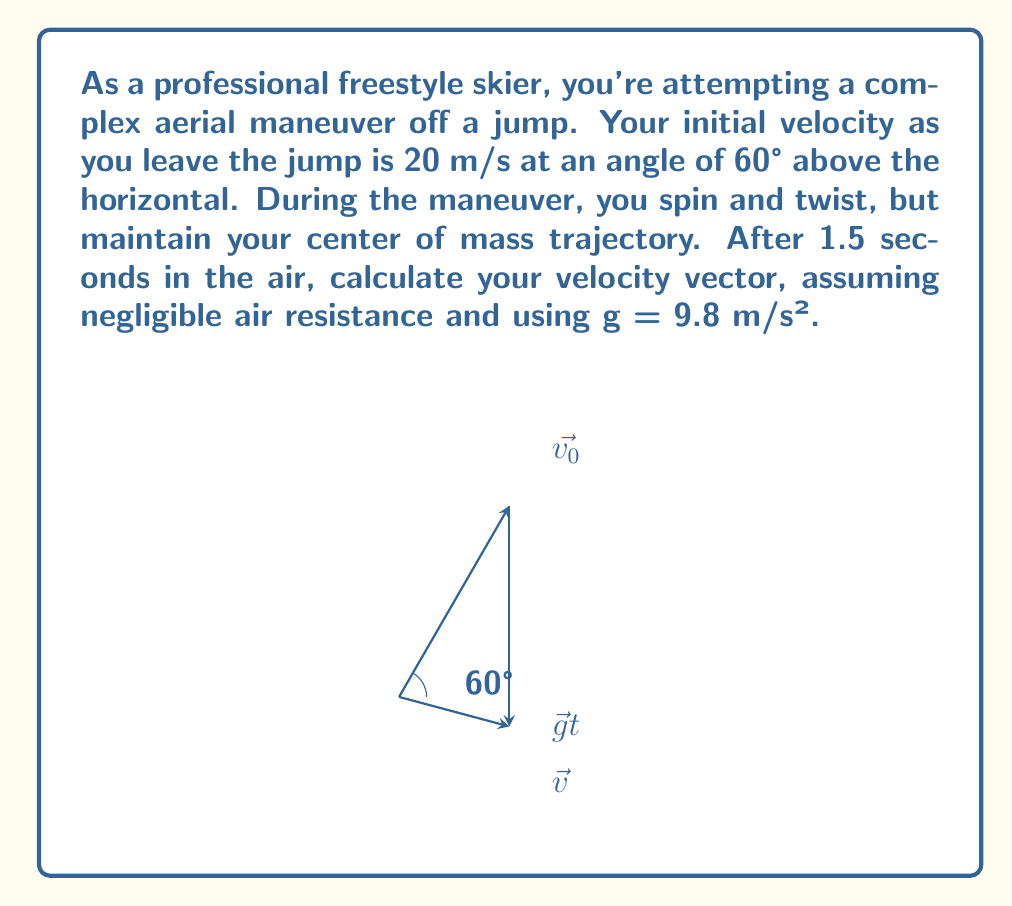Provide a solution to this math problem. Let's approach this step-by-step:

1) First, we need to break down the initial velocity into its x and y components:

   $v_{0x} = 20 \cos(60°) = 10$ m/s
   $v_{0y} = 20 \sin(60°) = 17.32$ m/s

2) Now, we can use the equations of motion to find the final velocity components:

   For x-component: There's no acceleration in the x-direction, so:
   $v_x = v_{0x} = 10$ m/s

   For y-component: We use $v_y = v_{0y} - gt$
   $v_y = 17.32 - (9.8)(1.5) = 2.62$ m/s

3) Now we have both components of the final velocity vector:

   $\vec{v} = (10\hat{i} + 2.62\hat{j})$ m/s

4) To find the magnitude of this vector:

   $|\vec{v}| = \sqrt{10^2 + 2.62^2} = 10.34$ m/s

5) To find the angle with the horizontal:

   $\theta = \tan^{-1}(\frac{2.62}{10}) = 14.67°$

Therefore, after 1.5 seconds, the skier's velocity vector has a magnitude of 10.34 m/s at an angle of 14.67° above the horizontal.
Answer: $\vec{v} = (10\hat{i} + 2.62\hat{j})$ m/s or 10.34 m/s at 14.67° above horizontal 